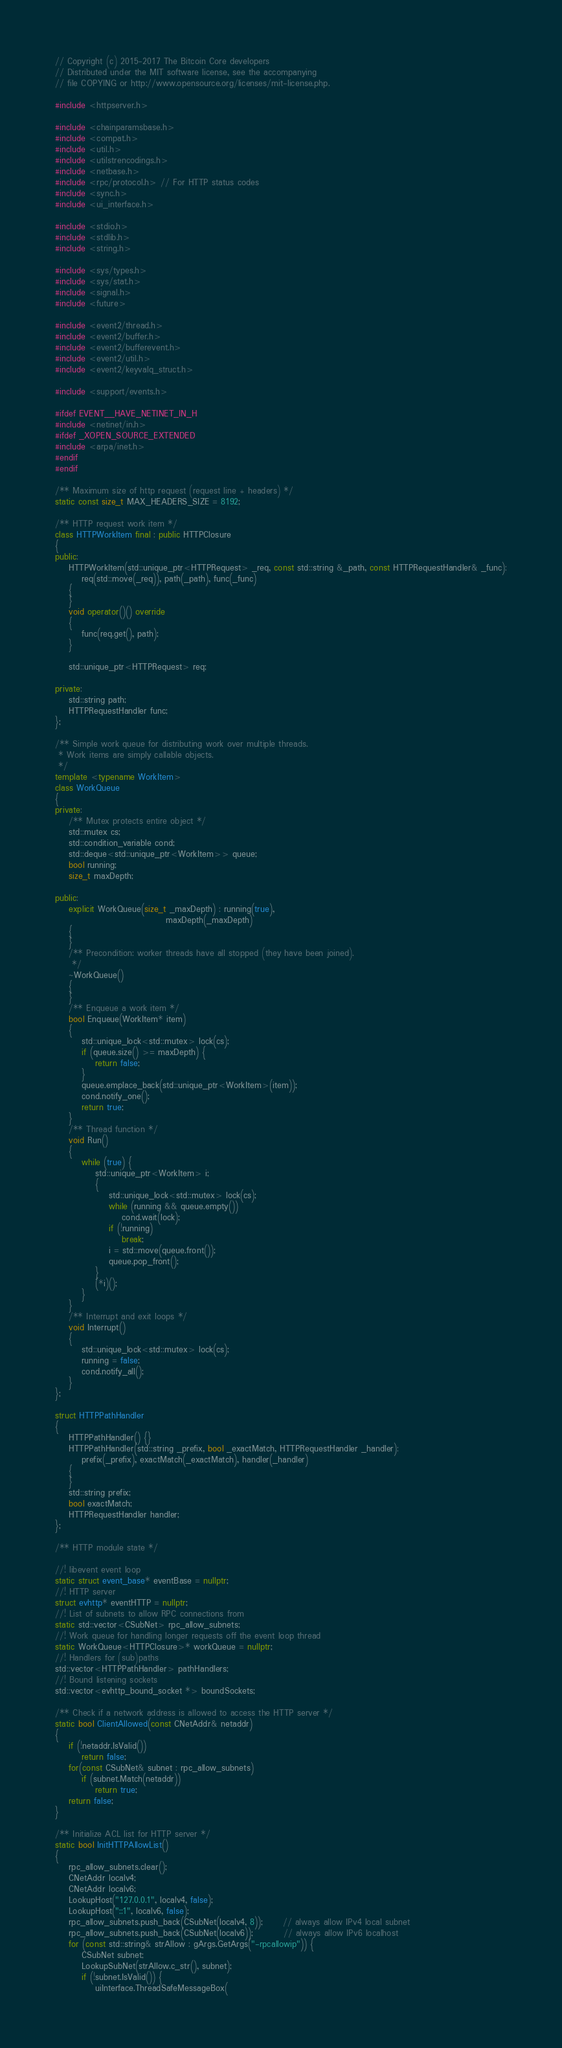<code> <loc_0><loc_0><loc_500><loc_500><_C++_>// Copyright (c) 2015-2017 The Bitcoin Core developers
// Distributed under the MIT software license, see the accompanying
// file COPYING or http://www.opensource.org/licenses/mit-license.php.

#include <httpserver.h>

#include <chainparamsbase.h>
#include <compat.h>
#include <util.h>
#include <utilstrencodings.h>
#include <netbase.h>
#include <rpc/protocol.h> // For HTTP status codes
#include <sync.h>
#include <ui_interface.h>

#include <stdio.h>
#include <stdlib.h>
#include <string.h>

#include <sys/types.h>
#include <sys/stat.h>
#include <signal.h>
#include <future>

#include <event2/thread.h>
#include <event2/buffer.h>
#include <event2/bufferevent.h>
#include <event2/util.h>
#include <event2/keyvalq_struct.h>

#include <support/events.h>

#ifdef EVENT__HAVE_NETINET_IN_H
#include <netinet/in.h>
#ifdef _XOPEN_SOURCE_EXTENDED
#include <arpa/inet.h>
#endif
#endif

/** Maximum size of http request (request line + headers) */
static const size_t MAX_HEADERS_SIZE = 8192;

/** HTTP request work item */
class HTTPWorkItem final : public HTTPClosure
{
public:
    HTTPWorkItem(std::unique_ptr<HTTPRequest> _req, const std::string &_path, const HTTPRequestHandler& _func):
        req(std::move(_req)), path(_path), func(_func)
    {
    }
    void operator()() override
    {
        func(req.get(), path);
    }

    std::unique_ptr<HTTPRequest> req;

private:
    std::string path;
    HTTPRequestHandler func;
};

/** Simple work queue for distributing work over multiple threads.
 * Work items are simply callable objects.
 */
template <typename WorkItem>
class WorkQueue
{
private:
    /** Mutex protects entire object */
    std::mutex cs;
    std::condition_variable cond;
    std::deque<std::unique_ptr<WorkItem>> queue;
    bool running;
    size_t maxDepth;

public:
    explicit WorkQueue(size_t _maxDepth) : running(true),
                                 maxDepth(_maxDepth)
    {
    }
    /** Precondition: worker threads have all stopped (they have been joined).
     */
    ~WorkQueue()
    {
    }
    /** Enqueue a work item */
    bool Enqueue(WorkItem* item)
    {
        std::unique_lock<std::mutex> lock(cs);
        if (queue.size() >= maxDepth) {
            return false;
        }
        queue.emplace_back(std::unique_ptr<WorkItem>(item));
        cond.notify_one();
        return true;
    }
    /** Thread function */
    void Run()
    {
        while (true) {
            std::unique_ptr<WorkItem> i;
            {
                std::unique_lock<std::mutex> lock(cs);
                while (running && queue.empty())
                    cond.wait(lock);
                if (!running)
                    break;
                i = std::move(queue.front());
                queue.pop_front();
            }
            (*i)();
        }
    }
    /** Interrupt and exit loops */
    void Interrupt()
    {
        std::unique_lock<std::mutex> lock(cs);
        running = false;
        cond.notify_all();
    }
};

struct HTTPPathHandler
{
    HTTPPathHandler() {}
    HTTPPathHandler(std::string _prefix, bool _exactMatch, HTTPRequestHandler _handler):
        prefix(_prefix), exactMatch(_exactMatch), handler(_handler)
    {
    }
    std::string prefix;
    bool exactMatch;
    HTTPRequestHandler handler;
};

/** HTTP module state */

//! libevent event loop
static struct event_base* eventBase = nullptr;
//! HTTP server
struct evhttp* eventHTTP = nullptr;
//! List of subnets to allow RPC connections from
static std::vector<CSubNet> rpc_allow_subnets;
//! Work queue for handling longer requests off the event loop thread
static WorkQueue<HTTPClosure>* workQueue = nullptr;
//! Handlers for (sub)paths
std::vector<HTTPPathHandler> pathHandlers;
//! Bound listening sockets
std::vector<evhttp_bound_socket *> boundSockets;

/** Check if a network address is allowed to access the HTTP server */
static bool ClientAllowed(const CNetAddr& netaddr)
{
    if (!netaddr.IsValid())
        return false;
    for(const CSubNet& subnet : rpc_allow_subnets)
        if (subnet.Match(netaddr))
            return true;
    return false;
}

/** Initialize ACL list for HTTP server */
static bool InitHTTPAllowList()
{
    rpc_allow_subnets.clear();
    CNetAddr localv4;
    CNetAddr localv6;
    LookupHost("127.0.0.1", localv4, false);
    LookupHost("::1", localv6, false);
    rpc_allow_subnets.push_back(CSubNet(localv4, 8));      // always allow IPv4 local subnet
    rpc_allow_subnets.push_back(CSubNet(localv6));         // always allow IPv6 localhost
    for (const std::string& strAllow : gArgs.GetArgs("-rpcallowip")) {
        CSubNet subnet;
        LookupSubNet(strAllow.c_str(), subnet);
        if (!subnet.IsValid()) {
            uiInterface.ThreadSafeMessageBox(</code> 